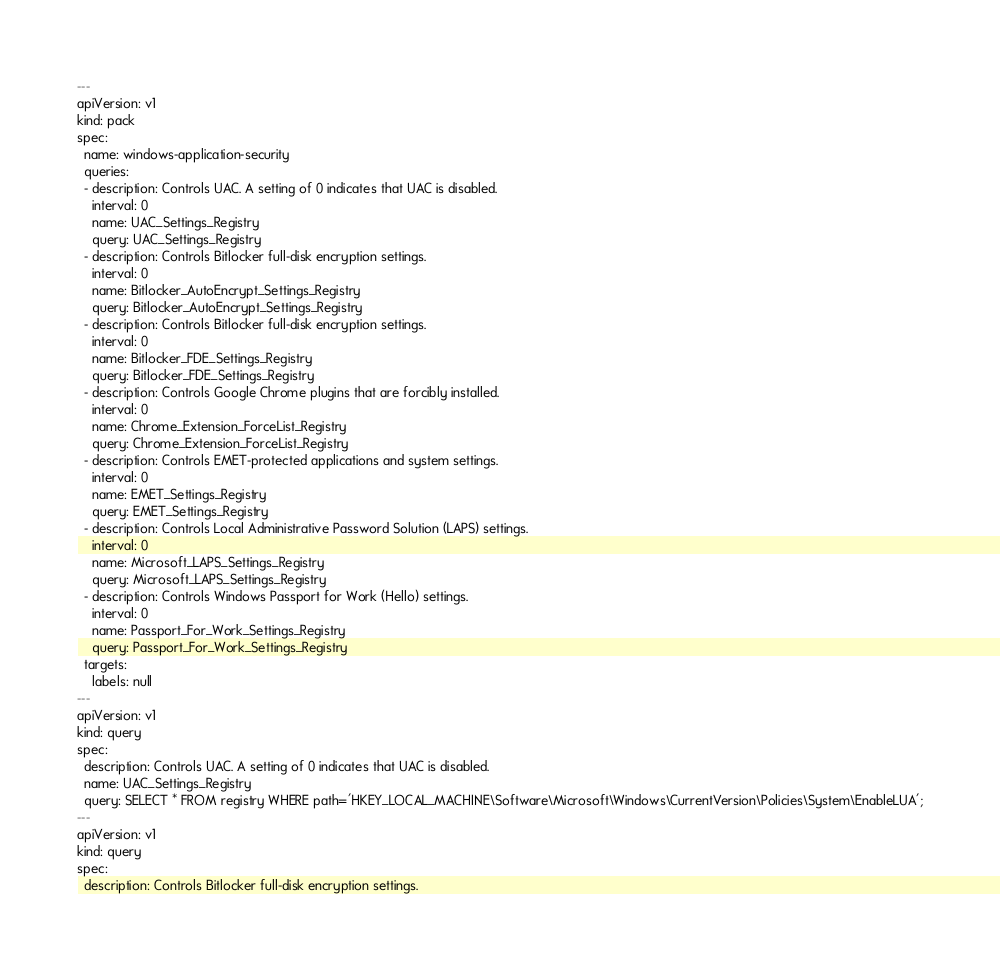<code> <loc_0><loc_0><loc_500><loc_500><_YAML_>---
apiVersion: v1
kind: pack
spec:
  name: windows-application-security
  queries:
  - description: Controls UAC. A setting of 0 indicates that UAC is disabled.
    interval: 0
    name: UAC_Settings_Registry
    query: UAC_Settings_Registry
  - description: Controls Bitlocker full-disk encryption settings.
    interval: 0
    name: Bitlocker_AutoEncrypt_Settings_Registry
    query: Bitlocker_AutoEncrypt_Settings_Registry
  - description: Controls Bitlocker full-disk encryption settings.
    interval: 0
    name: Bitlocker_FDE_Settings_Registry
    query: Bitlocker_FDE_Settings_Registry
  - description: Controls Google Chrome plugins that are forcibly installed.
    interval: 0
    name: Chrome_Extension_ForceList_Registry
    query: Chrome_Extension_ForceList_Registry
  - description: Controls EMET-protected applications and system settings.
    interval: 0
    name: EMET_Settings_Registry
    query: EMET_Settings_Registry
  - description: Controls Local Administrative Password Solution (LAPS) settings.
    interval: 0
    name: Microsoft_LAPS_Settings_Registry
    query: Microsoft_LAPS_Settings_Registry
  - description: Controls Windows Passport for Work (Hello) settings.
    interval: 0
    name: Passport_For_Work_Settings_Registry
    query: Passport_For_Work_Settings_Registry
  targets:
    labels: null
---
apiVersion: v1
kind: query
spec:
  description: Controls UAC. A setting of 0 indicates that UAC is disabled.
  name: UAC_Settings_Registry
  query: SELECT * FROM registry WHERE path='HKEY_LOCAL_MACHINE\Software\Microsoft\Windows\CurrentVersion\Policies\System\EnableLUA';
---
apiVersion: v1
kind: query
spec:
  description: Controls Bitlocker full-disk encryption settings.</code> 